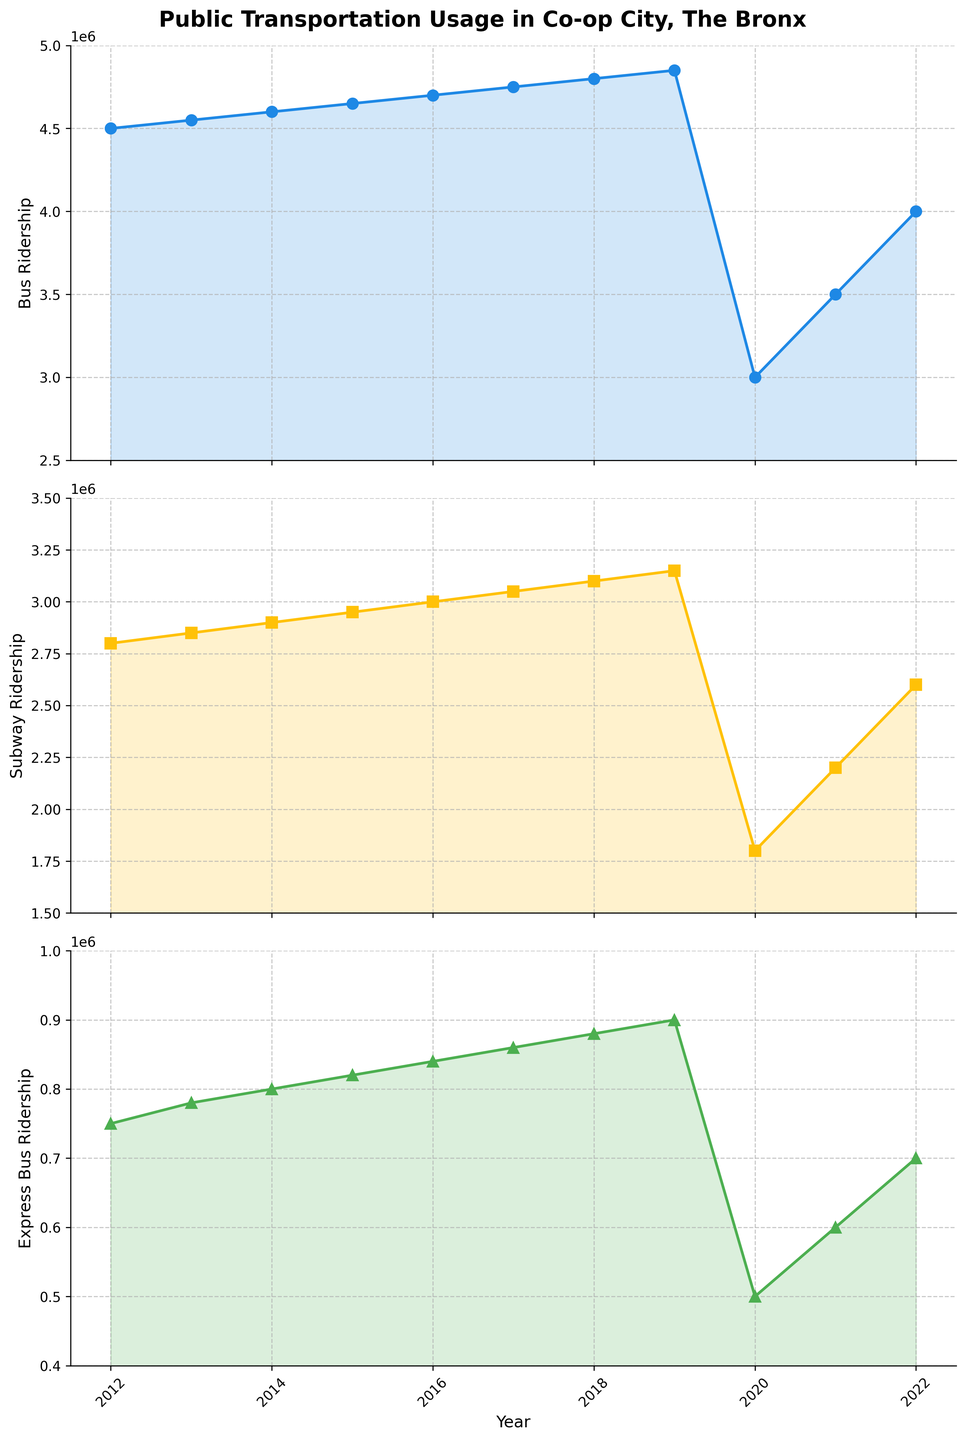What is the title of the figure? The title of the figure is usually bold and located at the top. In this case, it reads: "Public Transportation Usage in Co-op City, The Bronx".
Answer: Public Transportation Usage in Co-op City, The Bronx Which subplot shows the Subway Ridership trends? The subplot showing the Subway Ridership trends is the second one from the top. Both the vertical position and the label "Subway Ridership" on the y-axis help identify this.
Answer: The second subplot How many data points are there for Bus Ridership? Each year from 2012 to 2022 has a corresponding point for Bus Ridership, totaling 11 data points.
Answer: 11 What color is used to represent Express Bus Ridership? The colors used in the plots are distinct. The Express Bus Ridership is represented using a green color observed from its plot line and filled area.
Answer: Green In which year did Bus Ridership experience the largest decrease? From visual inspection, the sharpest drop in Bus Ridership is between 2019 and 2020.
Answer: 2020 By how much did Subway Ridership decrease from 2019 to 2020? In 2019, the Subway Ridership is 3,150,000, and in 2020, it is 1,800,000. The difference is 3,150,000 - 1,800,000 = 1,350,000.
Answer: 1,350,000 Which mode of transportation experienced the greatest decline in ridership due to the 2020 pandemic? By visual comparison, Bus Ridership dropped from approximately 4,850,000 to 3,000,000, Subway Ridership from 3,150,000 to 1,800,000, and Express Bus Ridership from 900,000 to 500,000. Bus Ridership declined by about 1,850,000, which is the greatest decrease.
Answer: Bus Ridership What is the overall trend in Express Bus Ridership from 2012 to 2022? Observing the green plot line and filled area for Express Bus Ridership, it shows a general upward trend over the decade with a peak drop in 2020 but picking up later.
Answer: Increasing In what year did Subway Ridership surpass 3,000,000 for the first time? Looking at the Subway Ridership plot, the first time it surpasses the 3,000,000 mark is in 2016.
Answer: 2016 Which of the three modes of transportation has the highest ridership in 2022? By comparing the data points at 2022 on all three plots, Bus Ridership (4,000,000) is the highest, followed by Subway (2,600,000) and Express Bus (700,000).
Answer: Bus Ridership 